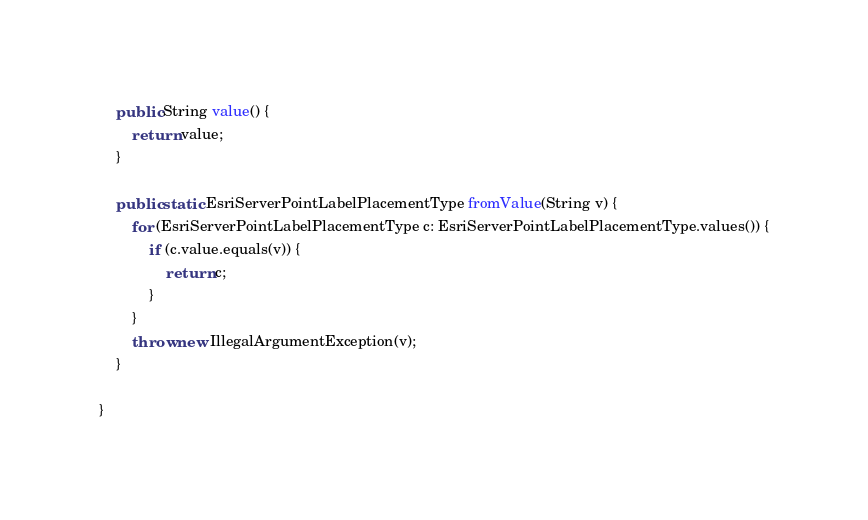<code> <loc_0><loc_0><loc_500><loc_500><_Java_>    public String value() {
        return value;
    }

    public static EsriServerPointLabelPlacementType fromValue(String v) {
        for (EsriServerPointLabelPlacementType c: EsriServerPointLabelPlacementType.values()) {
            if (c.value.equals(v)) {
                return c;
            }
        }
        throw new IllegalArgumentException(v);
    }

}
</code> 